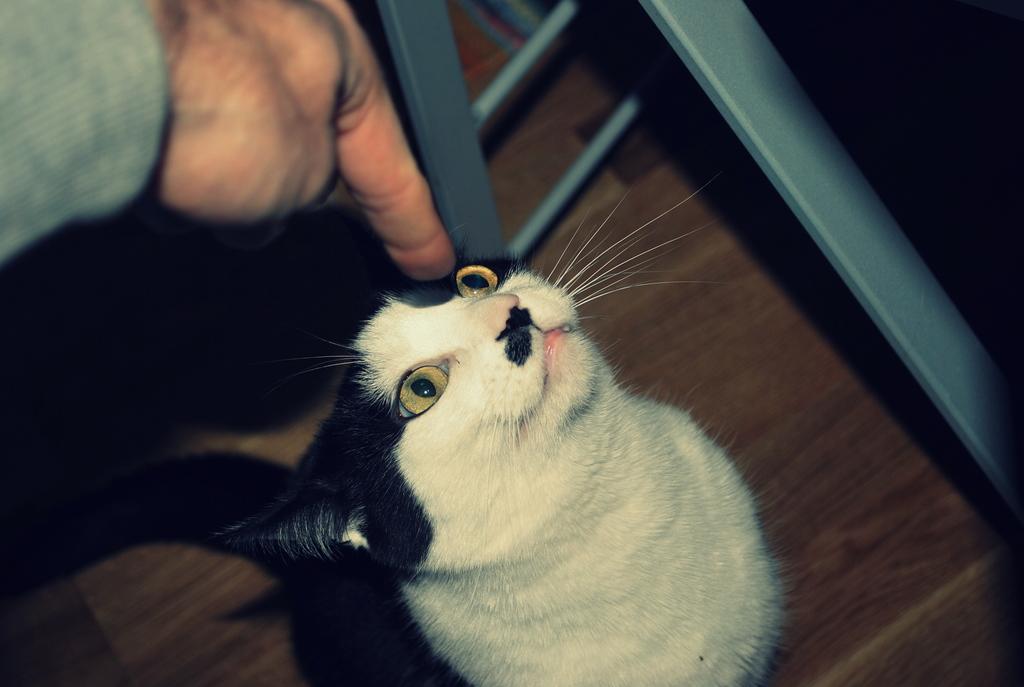In one or two sentences, can you explain what this image depicts? There is a cat. Cat is looking at the person. Cat is on the floor. There is a person in the left corner. 